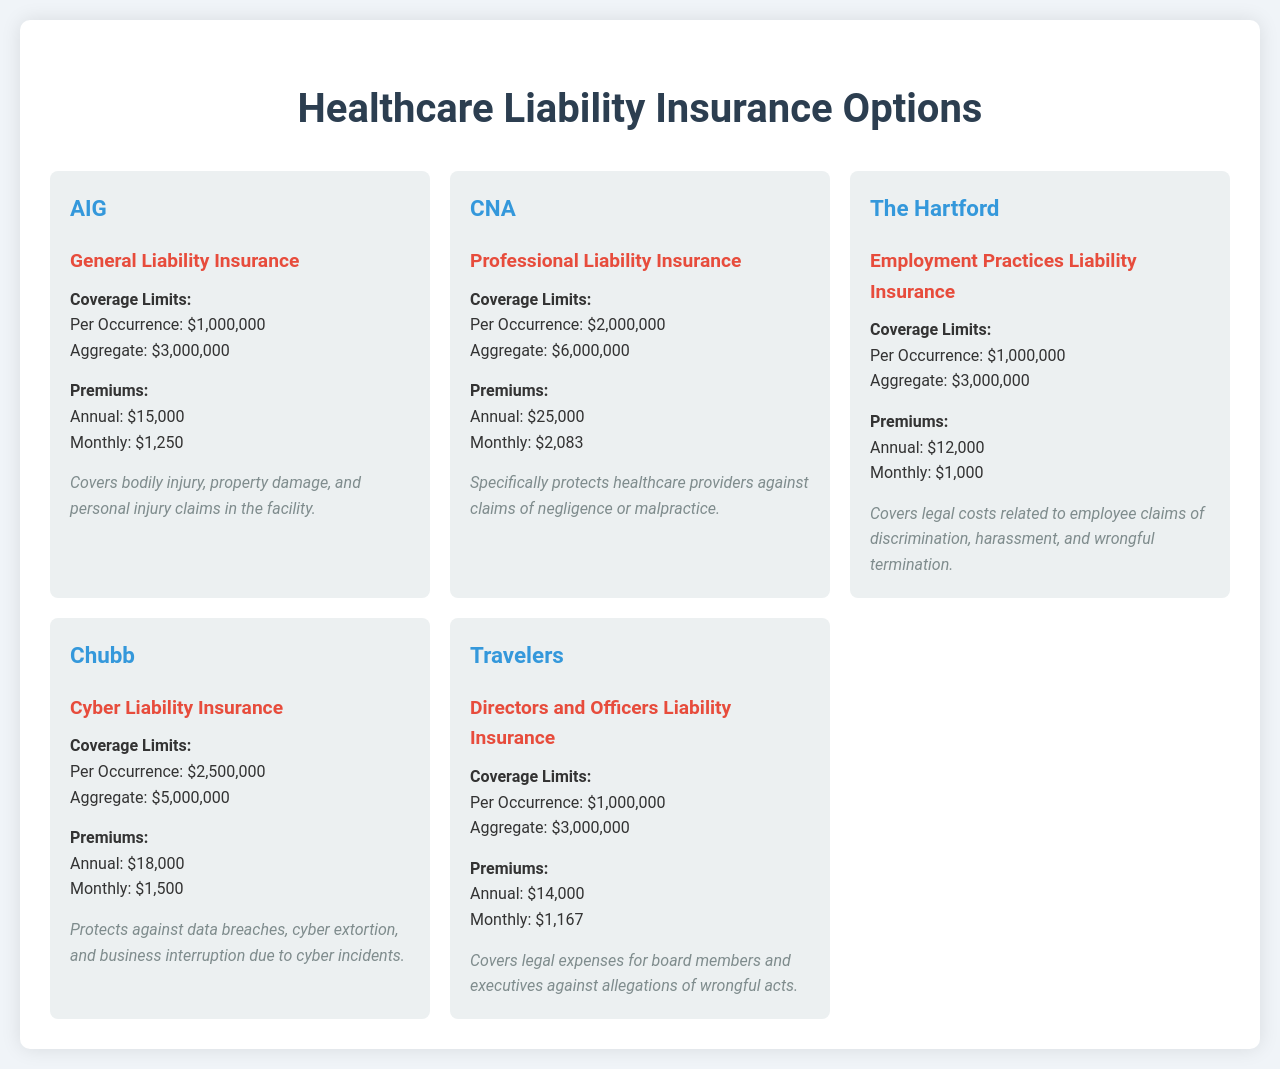What is the premium for AIG's General Liability Insurance? The premium for AIG's General Liability Insurance is stated as Annual: $15,000 and Monthly: $1,250.
Answer: $15,000 What are the coverage limits for CNA's Professional Liability Insurance? The coverage limits for CNA's Professional Liability Insurance are Per Occurrence: $2,000,000 and Aggregate: $6,000,000.
Answer: Per Occurrence: $2,000,000; Aggregate: $6,000,000 Which insurance covers employee claims of discrimination? The insurance that covers employee claims of discrimination is Employment Practices Liability Insurance provided by The Hartford.
Answer: Employment Practices Liability Insurance What is the monthly premium for Travel's Directors and Officers Liability Insurance? The monthly premium for Travel's Directors and Officers Liability Insurance is provided in the document as Monthly: $1,167.
Answer: $1,167 What is the aggregate coverage limit for Chubb's Cyber Liability Insurance? The aggregate coverage limit for Chubb's Cyber Liability Insurance is given as $5,000,000 in the document.
Answer: $5,000,000 Which insurer offers the lowest annual premium? The insurer that offers the lowest annual premium is The Hartford with an Annual premium of $12,000.
Answer: The Hartford How many types of liability insurance options are listed in the document? The document lists five types of liability insurance options.
Answer: Five What specific claims does CNA's insurance protect against? CNA's insurance specifically protects against claims of negligence or malpractice by healthcare providers.
Answer: Claims of negligence or malpractice What is the coverage limit per occurrence for The Hartford's insurance? The coverage limit per occurrence for The Hartford's insurance is $1,000,000.
Answer: $1,000,000 